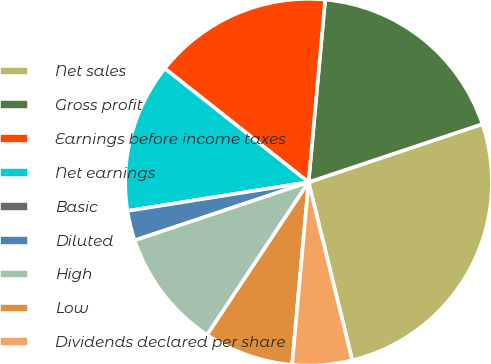<chart> <loc_0><loc_0><loc_500><loc_500><pie_chart><fcel>Net sales<fcel>Gross profit<fcel>Earnings before income taxes<fcel>Net earnings<fcel>Basic<fcel>Diluted<fcel>High<fcel>Low<fcel>Dividends declared per share<nl><fcel>26.31%<fcel>18.42%<fcel>15.79%<fcel>13.16%<fcel>0.0%<fcel>2.63%<fcel>10.53%<fcel>7.9%<fcel>5.26%<nl></chart> 